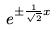<formula> <loc_0><loc_0><loc_500><loc_500>e ^ { \pm \frac { 1 } { \sqrt { 2 } } x }</formula> 